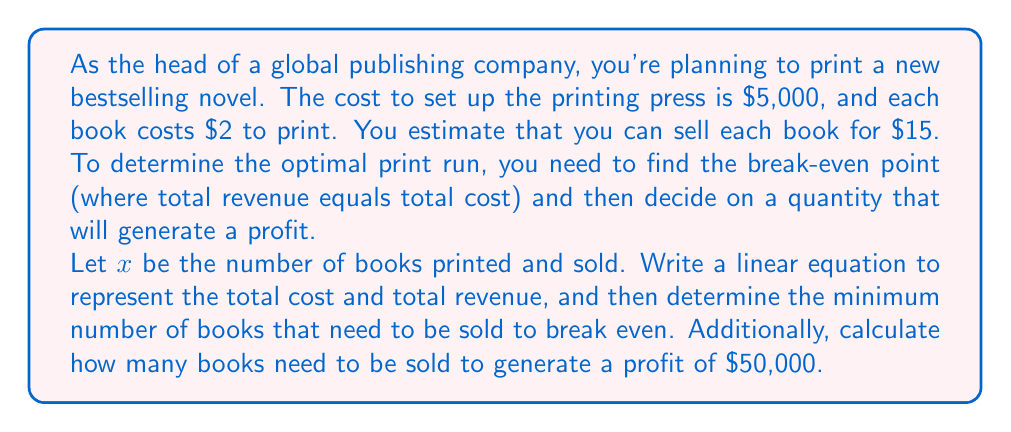Provide a solution to this math problem. Let's approach this step-by-step:

1) First, let's define our variables:
   $x$ = number of books printed and sold
   $TC$ = Total Cost
   $TR$ = Total Revenue

2) Now, let's write equations for Total Cost and Total Revenue:

   Total Cost: $TC = 5000 + 2x$
   (Fixed cost of $5,000 plus $2 per book)

   Total Revenue: $TR = 15x$
   ($15 per book sold)

3) To find the break-even point, we set TC = TR:

   $5000 + 2x = 15x$

4) Solve for x:
   $5000 = 15x - 2x$
   $5000 = 13x$
   $x = 5000 / 13 \approx 384.62$

5) Since we can't sell a fraction of a book, we round up to 385 books.

6) To verify, let's plug this back into our equations:
   $TC = 5000 + 2(385) = 5770$
   $TR = 15(385) = 5775$

   Indeed, revenue slightly exceeds cost at 385 books.

7) To find how many books need to be sold for a $50,000 profit, we set up:
   $TR - TC = 50000$
   $15x - (5000 + 2x) = 50000$
   $13x - 5000 = 50000$
   $13x = 55000$
   $x = 55000 / 13 \approx 4230.77$

8) Rounding up, we need to sell 4,231 books to make at least $50,000 profit.
Answer: Break-even point: 385 books
Books to sell for $50,000 profit: 4,231 books 